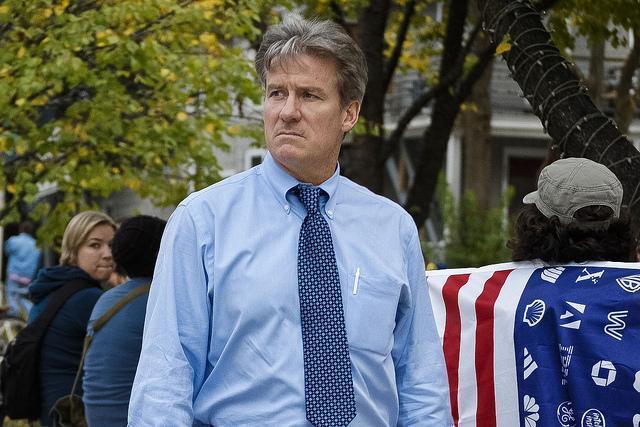How many people are there?
Give a very brief answer. 5. How many airplane engines can you see?
Give a very brief answer. 0. 